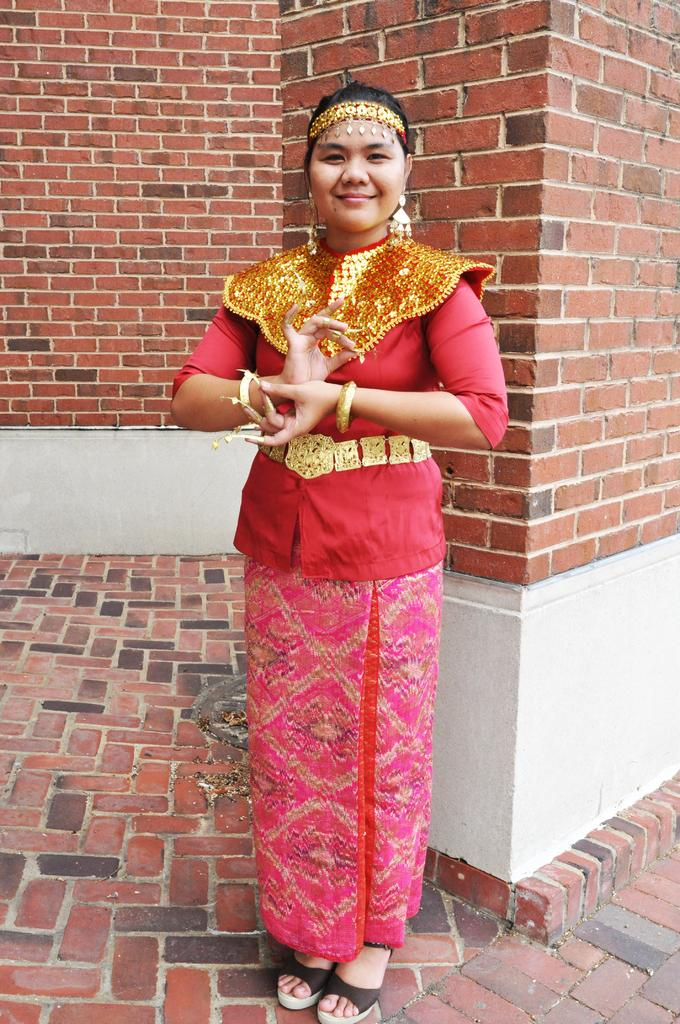Who is present in the image? There is a woman in the image. What is the woman's position in the image? The woman is standing on the floor. What type of structure can be seen in the background of the image? There is a brick wall in the background of the image. What type of creature is sitting on the woman's shoulder in the image? There is no creature present on the woman's shoulder in the image. What flavor of butter is being used in the image? There is no butter present in the image. 